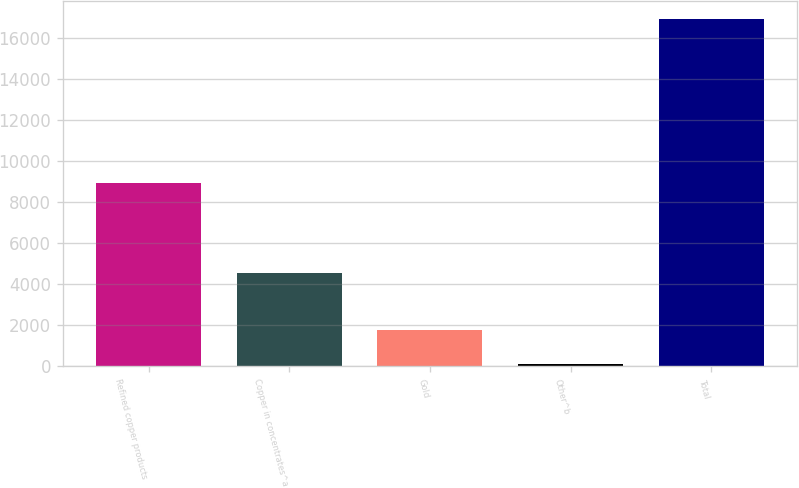Convert chart. <chart><loc_0><loc_0><loc_500><loc_500><bar_chart><fcel>Refined copper products<fcel>Copper in concentrates^a<fcel>Gold<fcel>Other^b<fcel>Total<nl><fcel>8918<fcel>4541<fcel>1795.6<fcel>113<fcel>16939<nl></chart> 